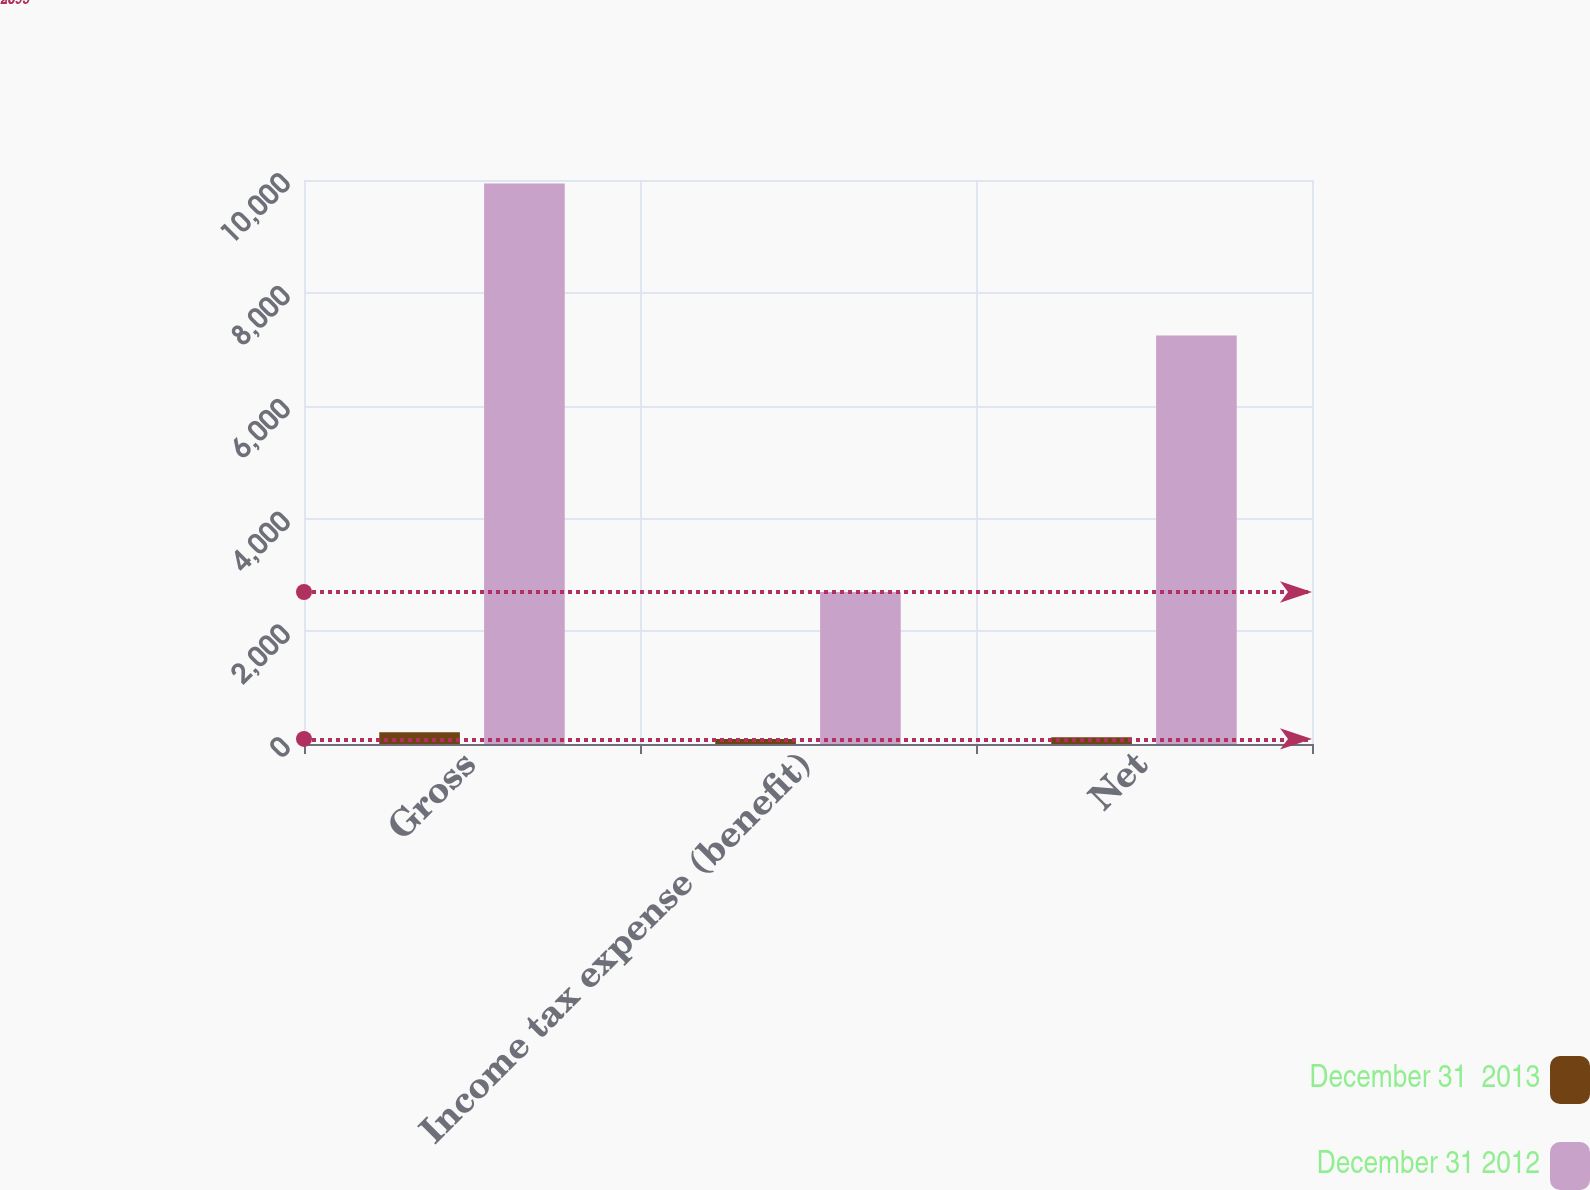<chart> <loc_0><loc_0><loc_500><loc_500><stacked_bar_chart><ecel><fcel>Gross<fcel>Income tax expense (benefit)<fcel>Net<nl><fcel>December 31  2013<fcel>208<fcel>90<fcel>118<nl><fcel>December 31 2012<fcel>9936<fcel>2695<fcel>7241<nl></chart> 